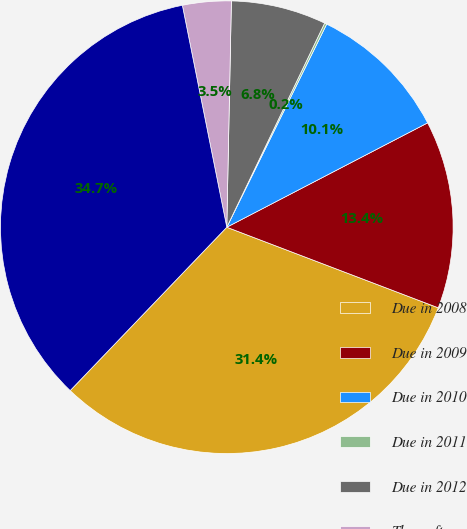Convert chart to OTSL. <chart><loc_0><loc_0><loc_500><loc_500><pie_chart><fcel>Due in 2008<fcel>Due in 2009<fcel>Due in 2010<fcel>Due in 2011<fcel>Due in 2012<fcel>Thereafter<fcel>Total time deposits<nl><fcel>31.37%<fcel>13.42%<fcel>10.1%<fcel>0.16%<fcel>6.79%<fcel>3.47%<fcel>34.69%<nl></chart> 